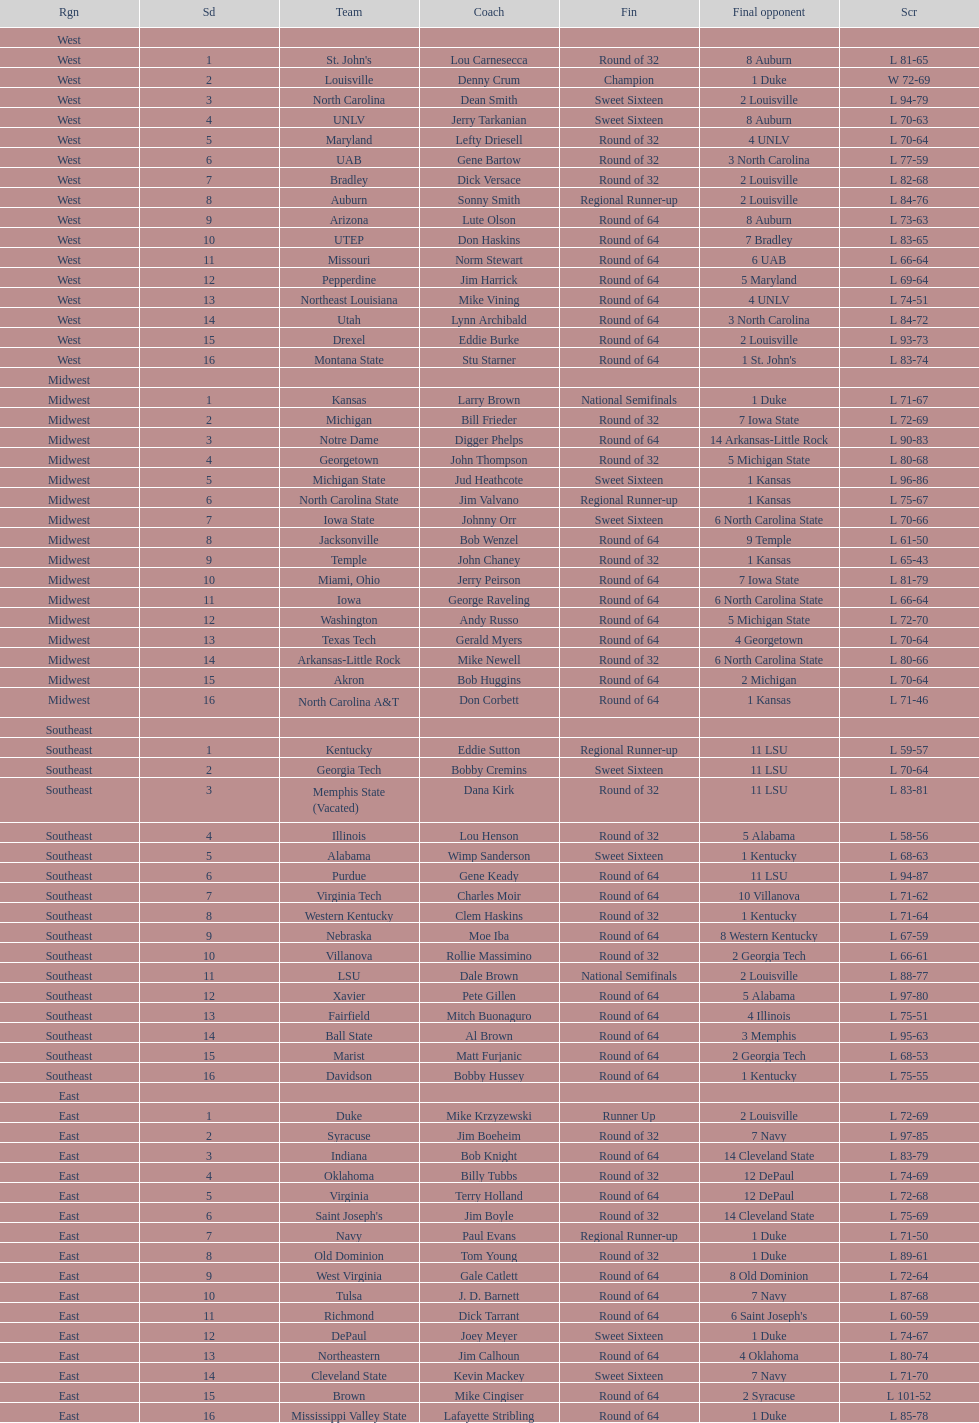How many number of teams played altogether? 64. 